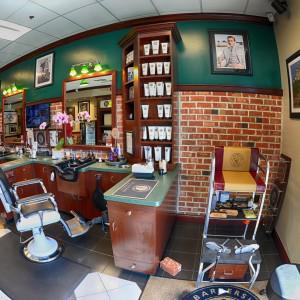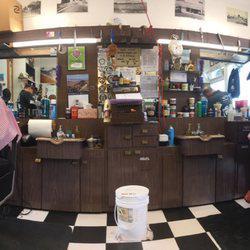The first image is the image on the left, the second image is the image on the right. Assess this claim about the two images: "There is exactly one television screen in the image on the right.". Correct or not? Answer yes or no. No. The first image is the image on the left, the second image is the image on the right. Given the left and right images, does the statement "The image on the right contains at least one person." hold true? Answer yes or no. Yes. 